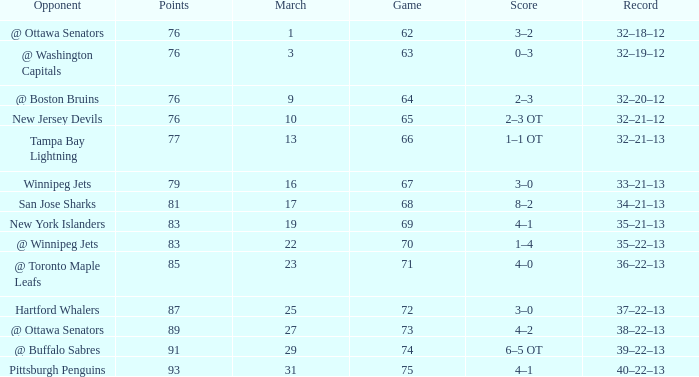Which Game is the lowest one that has a Score of 2–3 ot, and Points larger than 76? None. 